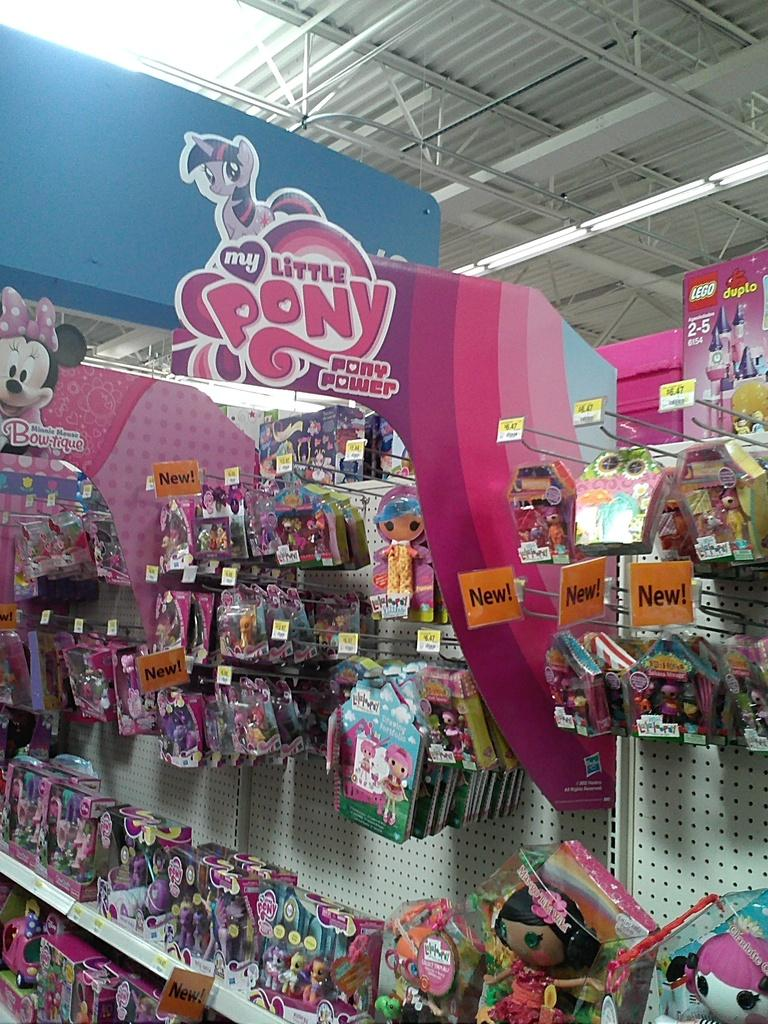<image>
Summarize the visual content of the image. A store section for the cartoon My Little Pony 